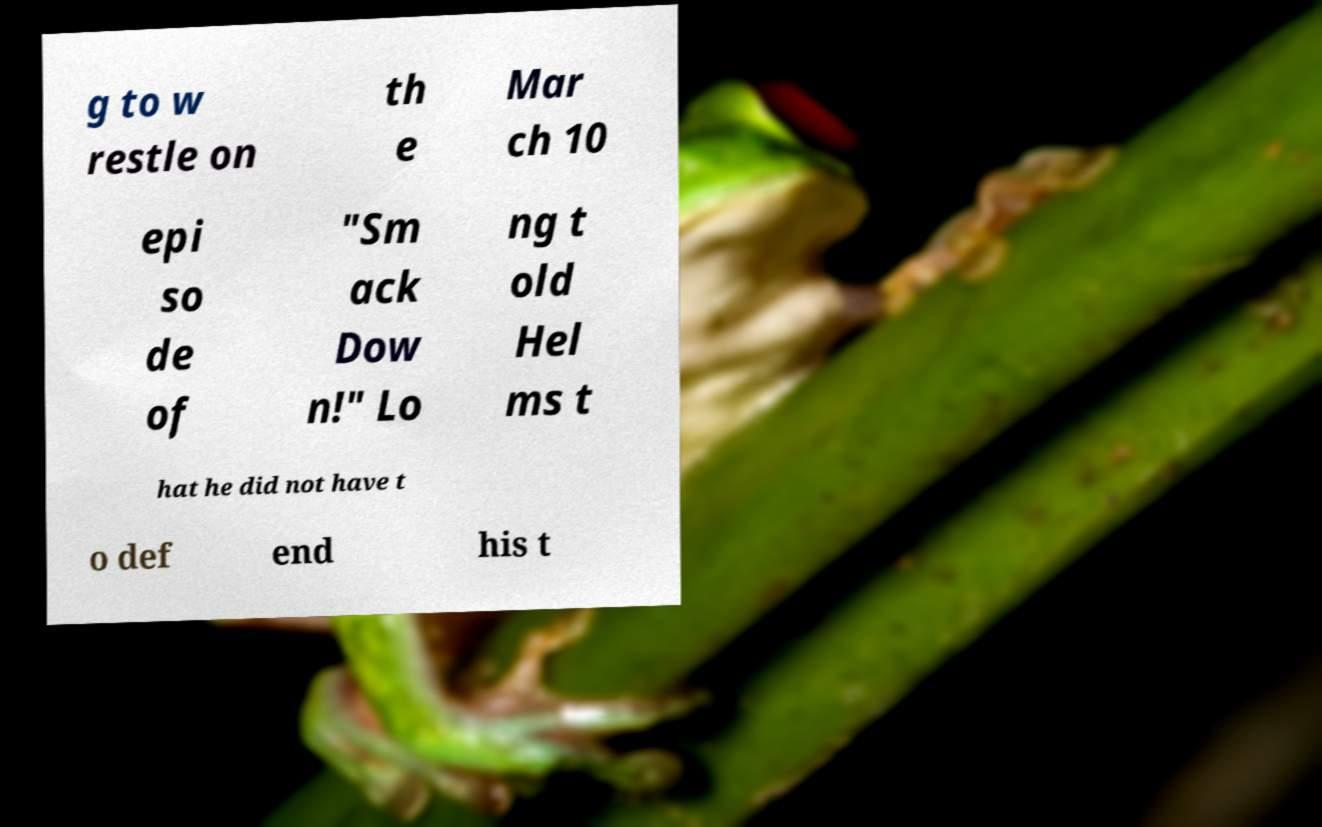Could you extract and type out the text from this image? g to w restle on th e Mar ch 10 epi so de of "Sm ack Dow n!" Lo ng t old Hel ms t hat he did not have t o def end his t 